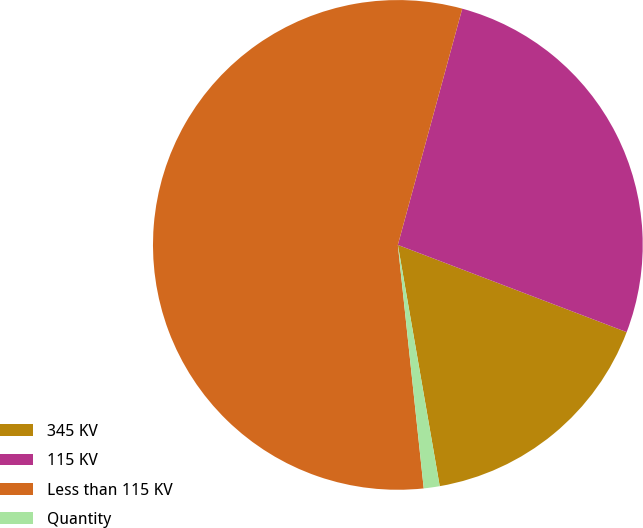Convert chart to OTSL. <chart><loc_0><loc_0><loc_500><loc_500><pie_chart><fcel>345 KV<fcel>115 KV<fcel>Less than 115 KV<fcel>Quantity<nl><fcel>16.47%<fcel>26.56%<fcel>55.92%<fcel>1.05%<nl></chart> 